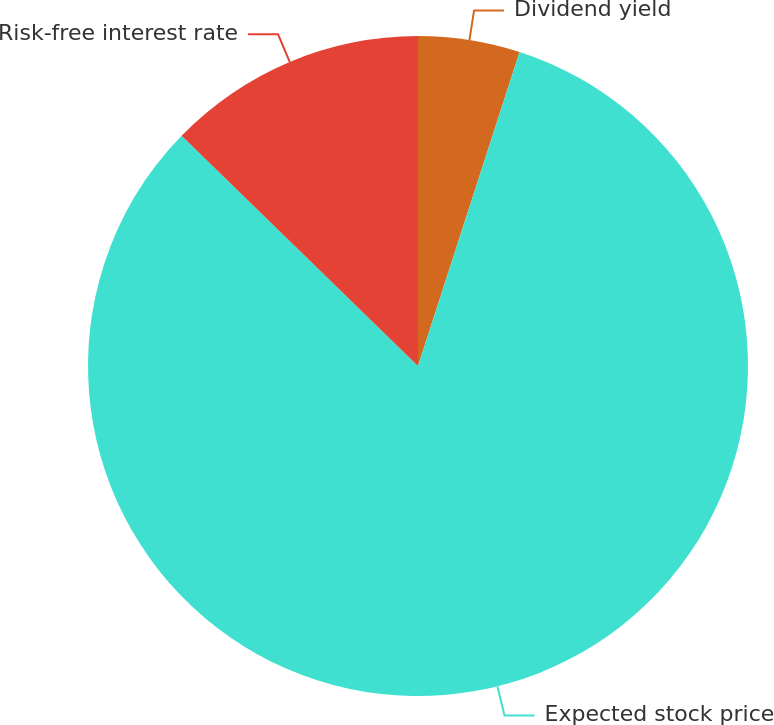Convert chart. <chart><loc_0><loc_0><loc_500><loc_500><pie_chart><fcel>Dividend yield<fcel>Expected stock price<fcel>Risk-free interest rate<nl><fcel>4.98%<fcel>82.31%<fcel>12.71%<nl></chart> 